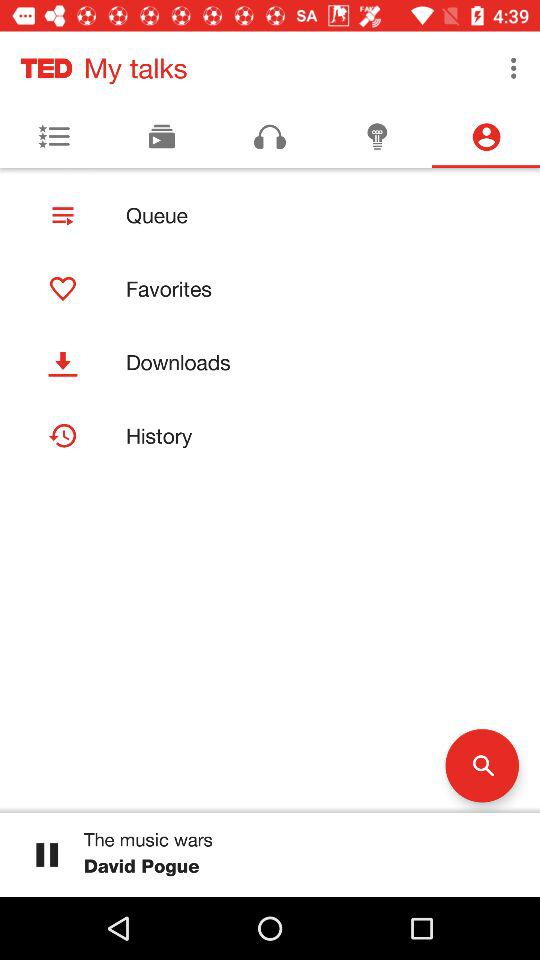Which tab am I on? You are on "Contacts" tab. 